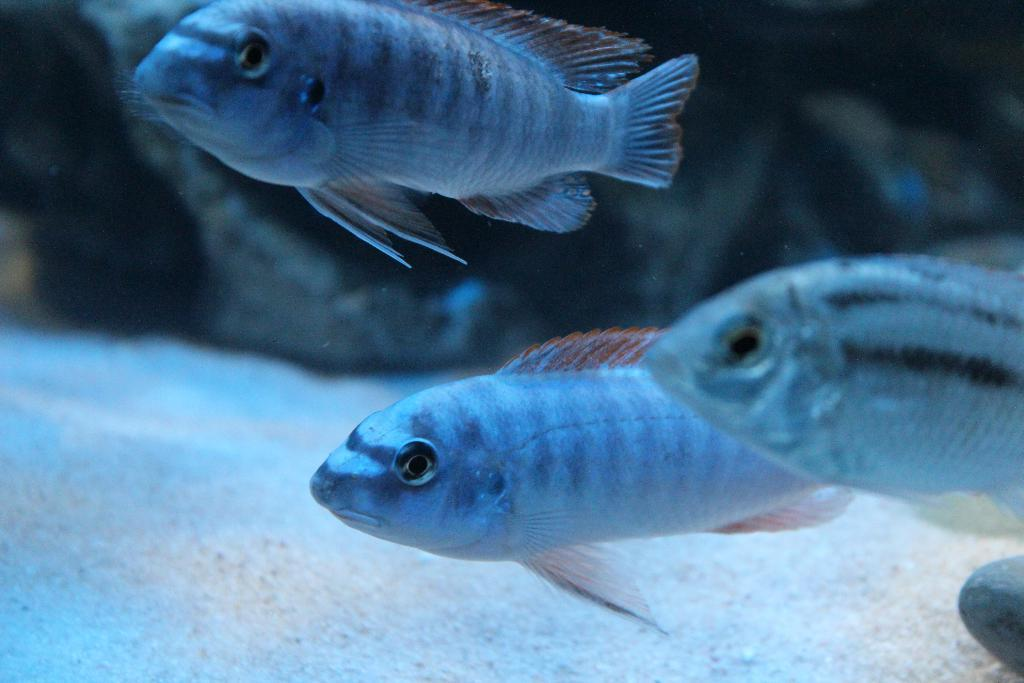Where is the image taken? The image is taken in the water. What can be seen at the bottom of the image? There is sand at the bottom of the image. What animals are present in the middle of the image? There are three fishes in the middle of the image. What type of object can be seen in the background of the image? There is a rock in the background of the image. How does the kettle stop boiling in the image? There is no kettle present in the image, so it cannot be stopped from boiling. 